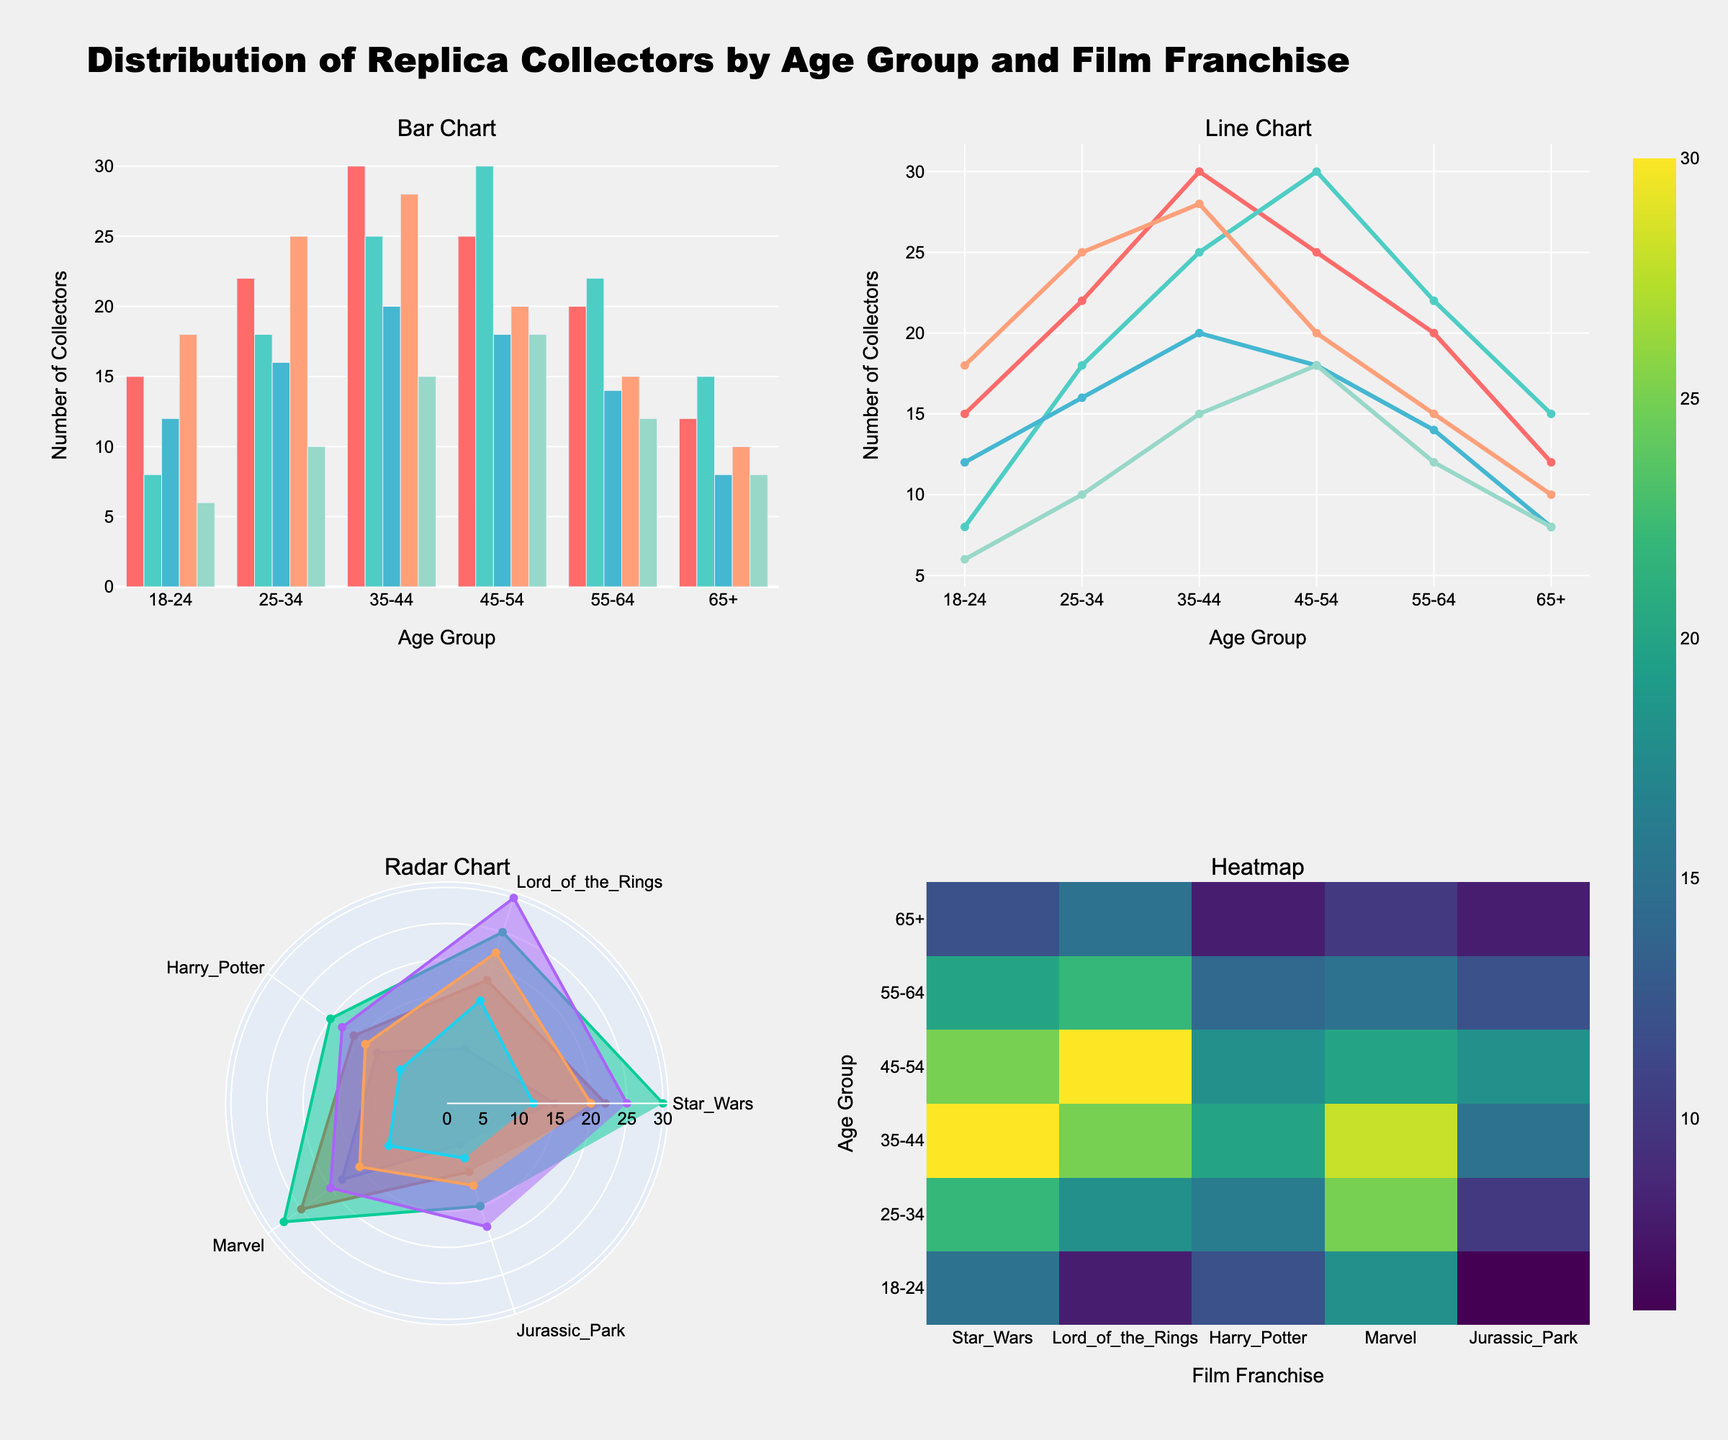Which age group has the most collectors for the "Star Wars" franchise according to the bar chart? Look at the bar chart subplot. Observe the bars representing different age groups for the "Star Wars" franchise. The age group 35-44 has the tallest bar.
Answer: 35-44 What is the overall trend for the "Marvel" franchise across different age groups in the line chart? Observe the line corresponding to the "Marvel" franchise in the line chart. The line starts high for younger age groups and gradually decreases for older age groups.
Answer: Decreasing In the radar chart, which age group shows the highest preference for the "Lord of the Rings" franchise? Look at the radar plot and find the series that reaches the farthest along the "Lord of the Rings" axis. The 45-54 age group extends the farthest.
Answer: 45-54 Between the 25-34 and 45-54 age groups, which one has a higher number of "Harry Potter" collectors based on the heatmap? Look at the heatmap. Find the cells corresponding to 25-34 and 45-54 age groups for "Harry Potter." Compare their values; 25-34 has 16 and 45-54 has 18.
Answer: 45-54 Which film franchise has the lowest number of collectors in the "65+" age group as shown in the bar chart? Find the bars that correspond to the "65+" age group and compare their heights. The "Harry Potter" bar is the shortest.
Answer: Harry Potter Do the "Star Wars" and "Marvel" franchises share the same trend across age groups in the line chart? Look at the lines for "Star Wars" and "Marvel." Compare their general directions. While "Star Wars" varies more, "Marvel" shows a clear downward trend. Thus, they do not share the same trend.
Answer: No How many collectors in total are there for the "Jurassic Park" franchise across all age groups in the bar chart? Sum the number of collectors for the "Jurassic Park" franchise across all age groups: 6 + 10 + 15 + 18 + 12 + 8 = 69.
Answer: 69 Which age group shows the most variety in preferences across different film franchises according to the radar chart? In the radar chart, observe which age group has the most uneven distribution across the franchises. The 35-44 age group has significant differences in preferences, shown by the spread in the radar chart.
Answer: 35-44 Comparing all age groups, which franchise has the most consistent number of collectors according to the heatmap? Look at the heatmap and identify which franchise has the least variation in colors across all age groups. The "Harry Potter" franchise appears most uniform in color.
Answer: Harry Potter 